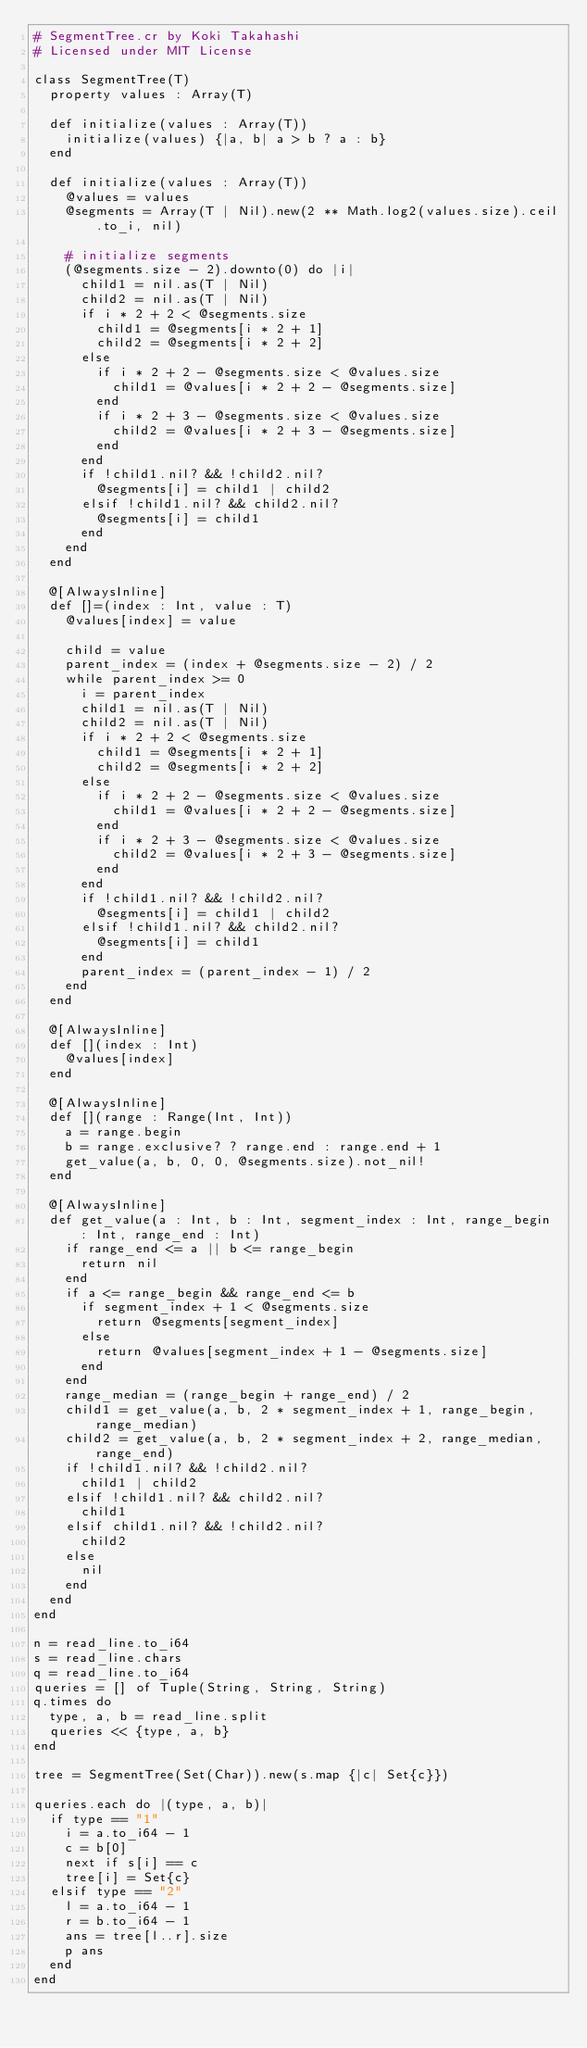Convert code to text. <code><loc_0><loc_0><loc_500><loc_500><_Crystal_># SegmentTree.cr by Koki Takahashi
# Licensed under MIT License

class SegmentTree(T)
  property values : Array(T)

  def initialize(values : Array(T))
    initialize(values) {|a, b| a > b ? a : b}
  end

  def initialize(values : Array(T))
    @values = values
    @segments = Array(T | Nil).new(2 ** Math.log2(values.size).ceil.to_i, nil)

    # initialize segments
    (@segments.size - 2).downto(0) do |i|
      child1 = nil.as(T | Nil)
      child2 = nil.as(T | Nil)
      if i * 2 + 2 < @segments.size
        child1 = @segments[i * 2 + 1]
        child2 = @segments[i * 2 + 2]
      else
        if i * 2 + 2 - @segments.size < @values.size
          child1 = @values[i * 2 + 2 - @segments.size]
        end
        if i * 2 + 3 - @segments.size < @values.size
          child2 = @values[i * 2 + 3 - @segments.size]
        end
      end
      if !child1.nil? && !child2.nil?
        @segments[i] = child1 | child2
      elsif !child1.nil? && child2.nil?
        @segments[i] = child1
      end
    end
  end

  @[AlwaysInline]
  def []=(index : Int, value : T)
    @values[index] = value

    child = value
    parent_index = (index + @segments.size - 2) / 2
    while parent_index >= 0
      i = parent_index
      child1 = nil.as(T | Nil)
      child2 = nil.as(T | Nil)
      if i * 2 + 2 < @segments.size
        child1 = @segments[i * 2 + 1]
        child2 = @segments[i * 2 + 2]
      else
        if i * 2 + 2 - @segments.size < @values.size
          child1 = @values[i * 2 + 2 - @segments.size]
        end
        if i * 2 + 3 - @segments.size < @values.size
          child2 = @values[i * 2 + 3 - @segments.size]
        end
      end
      if !child1.nil? && !child2.nil?
        @segments[i] = child1 | child2
      elsif !child1.nil? && child2.nil?
        @segments[i] = child1
      end
      parent_index = (parent_index - 1) / 2
    end
  end

  @[AlwaysInline]
  def [](index : Int)
    @values[index]
  end

  @[AlwaysInline]
  def [](range : Range(Int, Int))
    a = range.begin
    b = range.exclusive? ? range.end : range.end + 1
    get_value(a, b, 0, 0, @segments.size).not_nil!
  end

  @[AlwaysInline]
  def get_value(a : Int, b : Int, segment_index : Int, range_begin : Int, range_end : Int)
    if range_end <= a || b <= range_begin
      return nil
    end
    if a <= range_begin && range_end <= b
      if segment_index + 1 < @segments.size
        return @segments[segment_index]
      else
        return @values[segment_index + 1 - @segments.size]
      end
    end
    range_median = (range_begin + range_end) / 2
    child1 = get_value(a, b, 2 * segment_index + 1, range_begin, range_median)
    child2 = get_value(a, b, 2 * segment_index + 2, range_median, range_end)
    if !child1.nil? && !child2.nil?
      child1 | child2
    elsif !child1.nil? && child2.nil?
      child1
    elsif child1.nil? && !child2.nil?
      child2
    else
      nil
    end
  end
end

n = read_line.to_i64
s = read_line.chars
q = read_line.to_i64
queries = [] of Tuple(String, String, String)
q.times do
  type, a, b = read_line.split
  queries << {type, a, b}
end

tree = SegmentTree(Set(Char)).new(s.map {|c| Set{c}})

queries.each do |(type, a, b)|
  if type == "1"
    i = a.to_i64 - 1
    c = b[0]
    next if s[i] == c
    tree[i] = Set{c}
  elsif type == "2"
    l = a.to_i64 - 1
    r = b.to_i64 - 1
    ans = tree[l..r].size
    p ans
  end
end</code> 